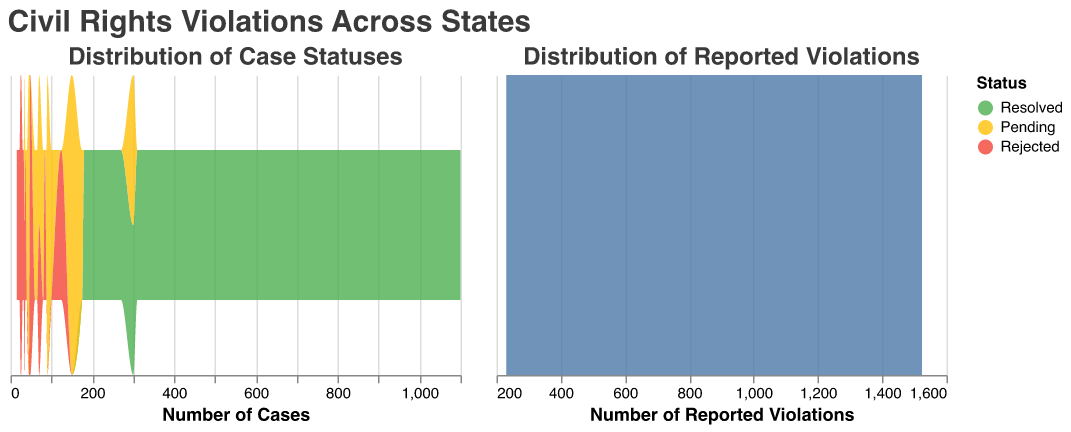What is the title of the figure? The title of the figure is located at the top and it reads "Civil Rights Violations Across States".
Answer: Civil Rights Violations Across States How many states are represented in the figure? By counting the distinct entries in the data section for the states, we find there are 16 states represented.
Answer: 16 What colors represent the 'Resolved', 'Pending', and 'Rejected' statuses in the distribution of case statuses plot? The 'Resolved' status is represented by green, the 'Pending' status by yellow, and the 'Rejected' status by red.
Answer: Green, Yellow, Red Which state has the highest number of reported violations? Looking at the data, California has the highest number of reported violations, which is 1524.
Answer: California What is the combined count of 'Pending' and 'Rejected' cases for New York? The 'Pending' cases for New York are 150 and the 'Rejected' cases are 70. Adding these together gives 150 + 70 = 220.
Answer: 220 Which state has the lowest number of reported violations? The state with the lowest number of reported violations is Indiana, with 230 reported violations.
Answer: Indiana Compare the number of resolved cases in Florida and Texas. Which state has fewer resolved cases and by how much? Florida has 600 resolved cases whereas Texas has 700 resolved cases. The difference is 700 - 600 = 100 cases. Therefore, Florida has fewer resolved cases by 100.
Answer: Florida by 100 What's the average number of pending cases across all states? The total number of pending cases across all states is the sum of the 'Pending' cases for each state: 300 + 150 + 150 + 175 + 100 + 80 + 70 + 90 + 88 + 90 + 65 + 60 + 40 + 45 + 45 + 35 = 1583. Dividing by the number of states, we get 1583 / 16 = 98.9375, approximately 99.
Answer: 99 What is the total number of resolved cases across all states? The total number of resolved cases is the sum of the 'Resolved' cases for each state: 1100 + 700 + 812 + 600 + 565 + 400 + 350 + 360 + 375 + 310 + 300 + 270 + 250 + 220 + 195 + 180 = 7687.
Answer: 7687 Are there more resolved cases or rejected cases in Ohio? By how much? Ohio has 350 resolved cases and 36 rejected cases. The difference is 350 - 36 = 314, so there are 314 more resolved cases than rejected cases.
Answer: Resolved by 314 